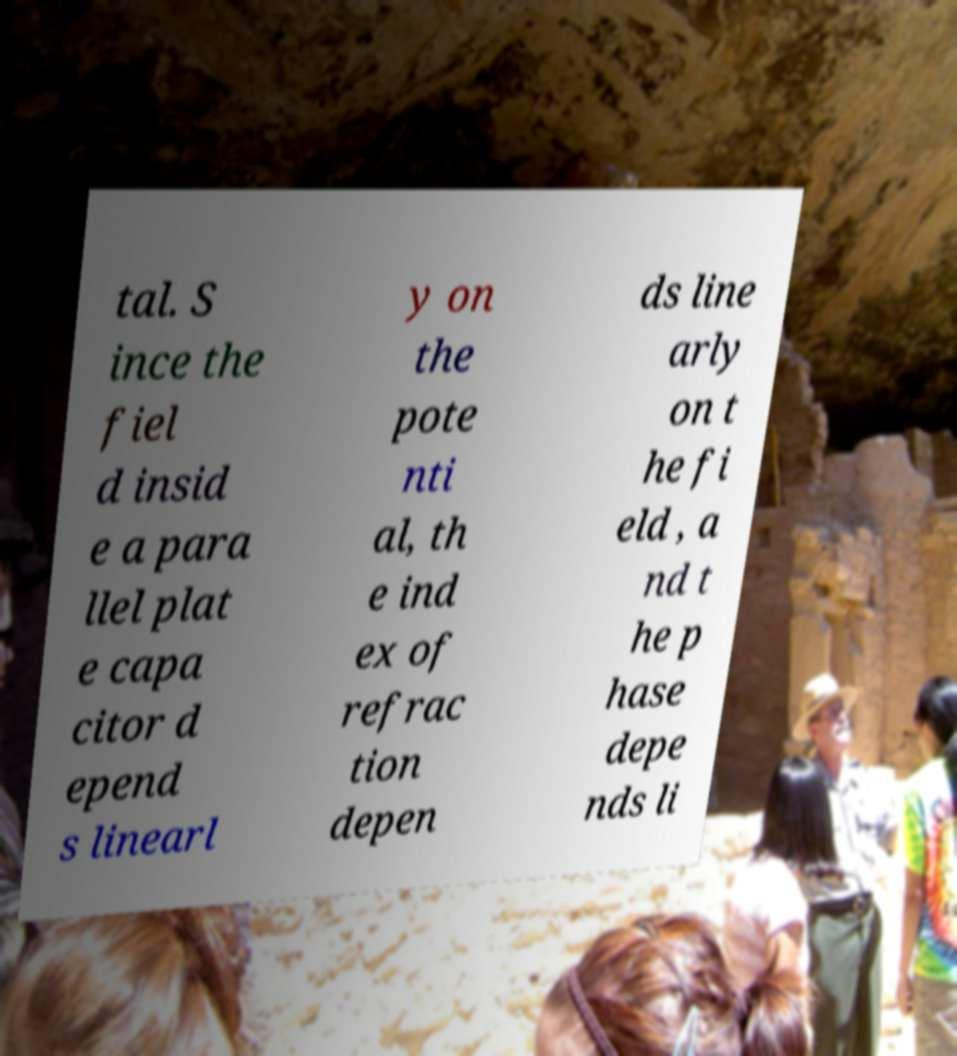There's text embedded in this image that I need extracted. Can you transcribe it verbatim? tal. S ince the fiel d insid e a para llel plat e capa citor d epend s linearl y on the pote nti al, th e ind ex of refrac tion depen ds line arly on t he fi eld , a nd t he p hase depe nds li 